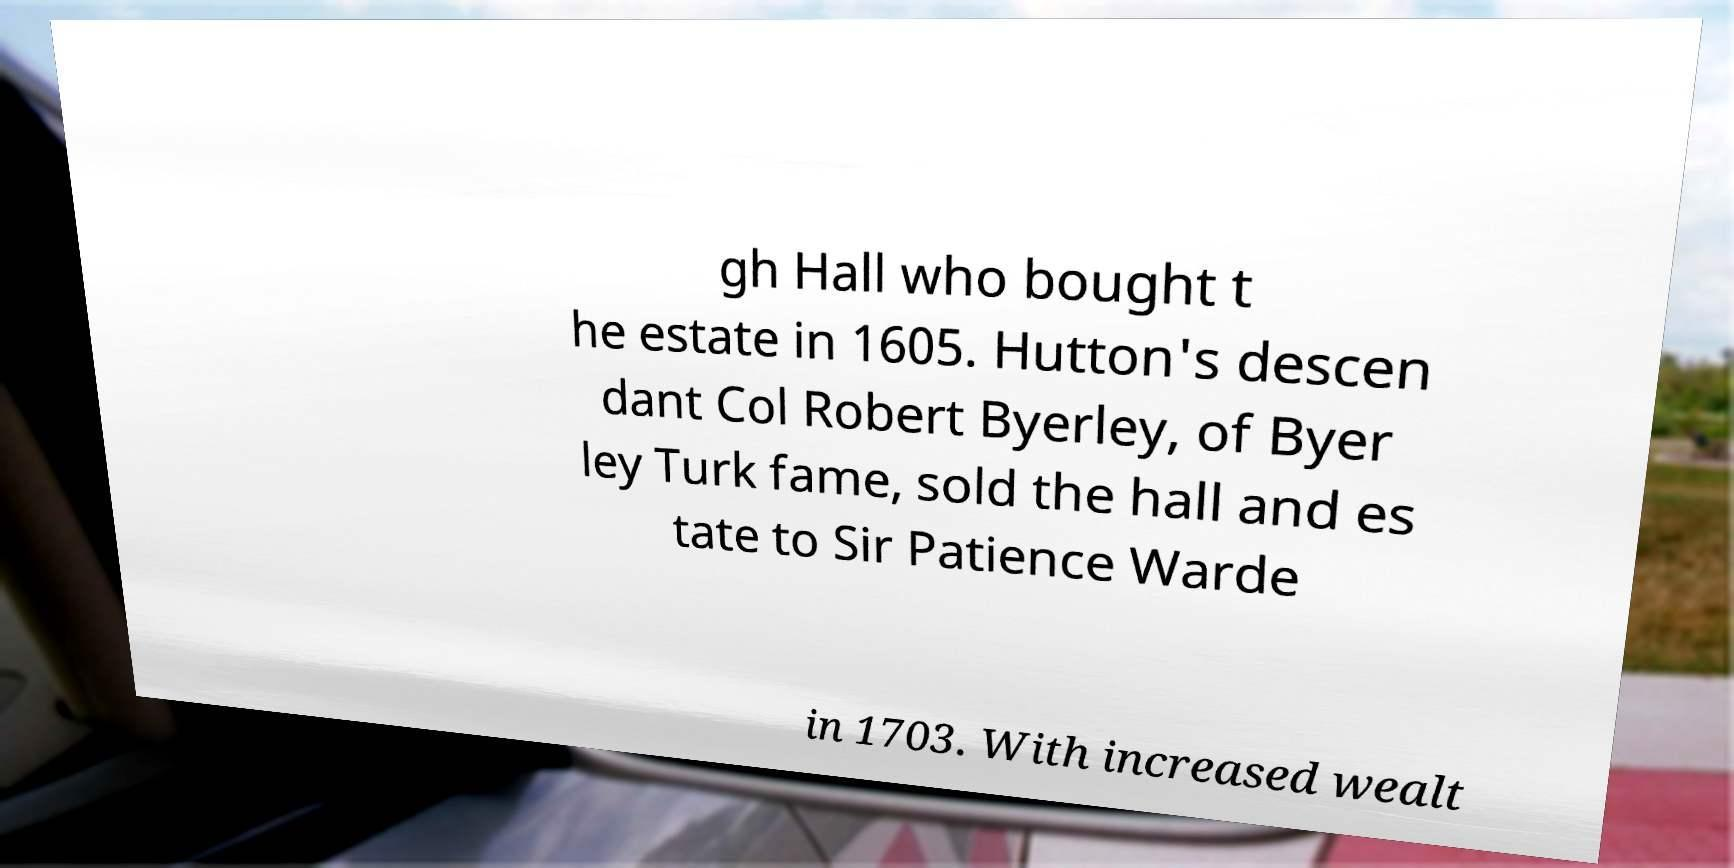I need the written content from this picture converted into text. Can you do that? gh Hall who bought t he estate in 1605. Hutton's descen dant Col Robert Byerley, of Byer ley Turk fame, sold the hall and es tate to Sir Patience Warde in 1703. With increased wealt 